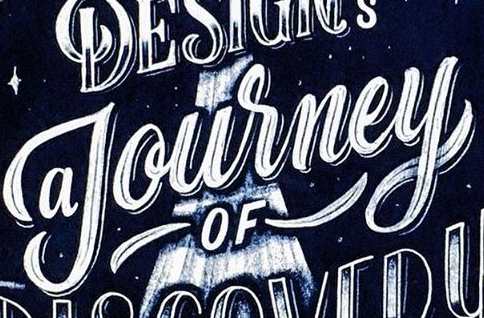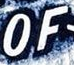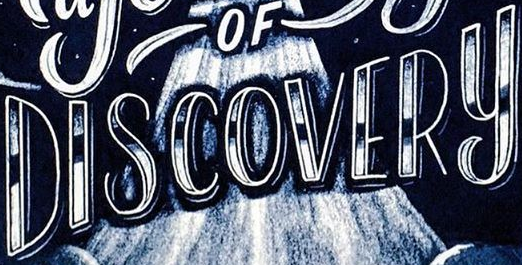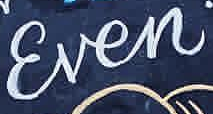Identify the words shown in these images in order, separated by a semicolon. Journey; OF; DISCOVERY; Ɛven 